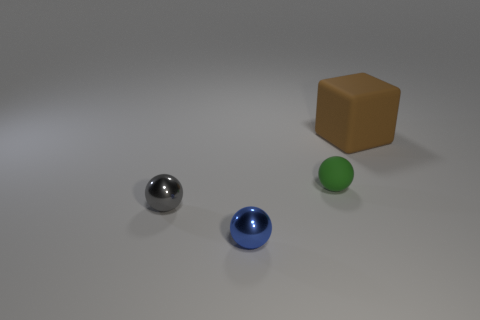Is there a small rubber block of the same color as the big rubber thing?
Ensure brevity in your answer.  No. What number of metallic things are either tiny gray spheres or big cyan cylinders?
Make the answer very short. 1. There is a metallic thing that is behind the small blue ball; what number of matte cubes are in front of it?
Your answer should be very brief. 0. What number of brown objects have the same material as the gray thing?
Offer a terse response. 0. What number of small objects are cubes or yellow spheres?
Provide a succinct answer. 0. There is a thing that is behind the tiny gray metal thing and in front of the big thing; what is its shape?
Give a very brief answer. Sphere. Is the brown thing made of the same material as the tiny gray ball?
Make the answer very short. No. There is a rubber sphere that is the same size as the blue metal object; what is its color?
Keep it short and to the point. Green. What is the color of the thing that is both to the right of the gray metallic object and in front of the tiny green matte thing?
Your response must be concise. Blue. There is a matte object that is to the right of the small sphere behind the small metal object on the left side of the blue shiny thing; what size is it?
Provide a succinct answer. Large. 